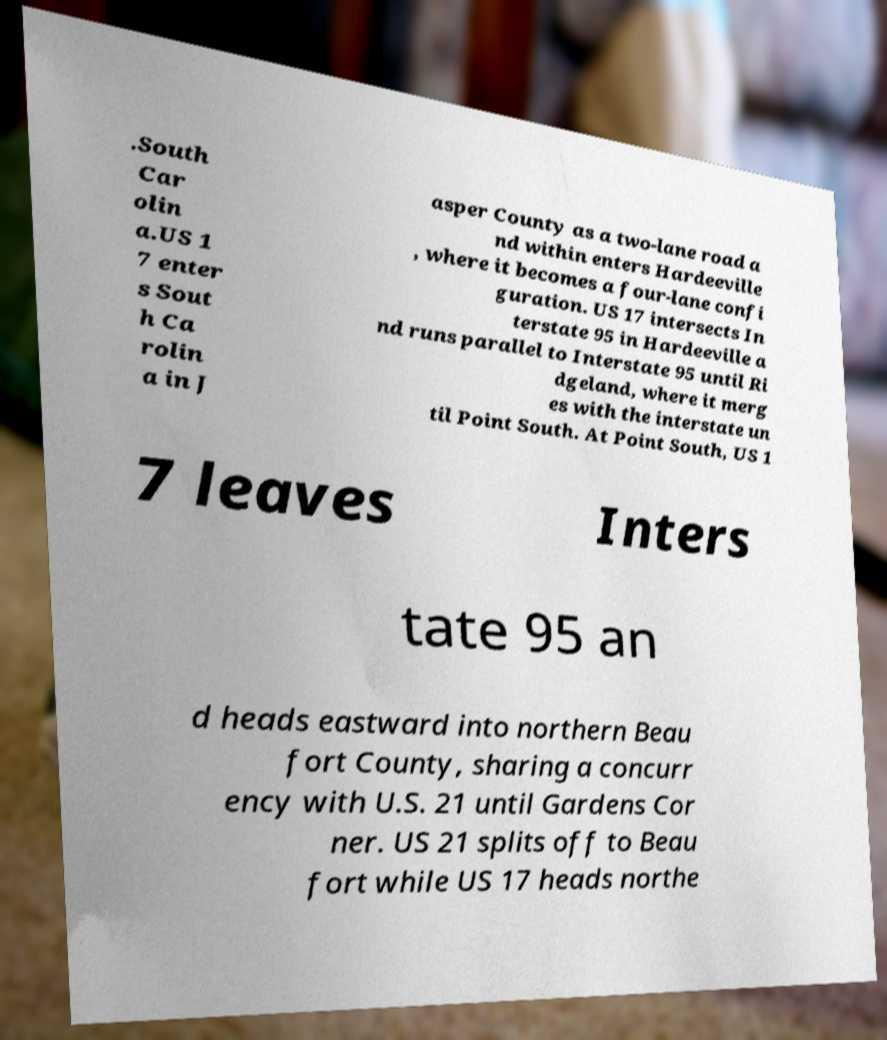Can you read and provide the text displayed in the image?This photo seems to have some interesting text. Can you extract and type it out for me? .South Car olin a.US 1 7 enter s Sout h Ca rolin a in J asper County as a two-lane road a nd within enters Hardeeville , where it becomes a four-lane confi guration. US 17 intersects In terstate 95 in Hardeeville a nd runs parallel to Interstate 95 until Ri dgeland, where it merg es with the interstate un til Point South. At Point South, US 1 7 leaves Inters tate 95 an d heads eastward into northern Beau fort County, sharing a concurr ency with U.S. 21 until Gardens Cor ner. US 21 splits off to Beau fort while US 17 heads northe 